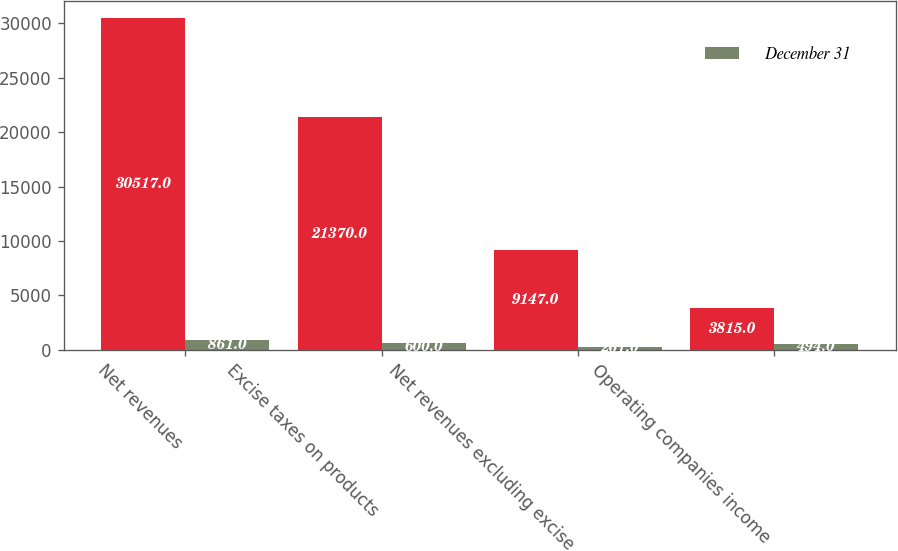Convert chart to OTSL. <chart><loc_0><loc_0><loc_500><loc_500><stacked_bar_chart><ecel><fcel>Net revenues<fcel>Excise taxes on products<fcel>Net revenues excluding excise<fcel>Operating companies income<nl><fcel>nan<fcel>30517<fcel>21370<fcel>9147<fcel>3815<nl><fcel>December 31<fcel>861<fcel>600<fcel>261<fcel>494<nl></chart> 